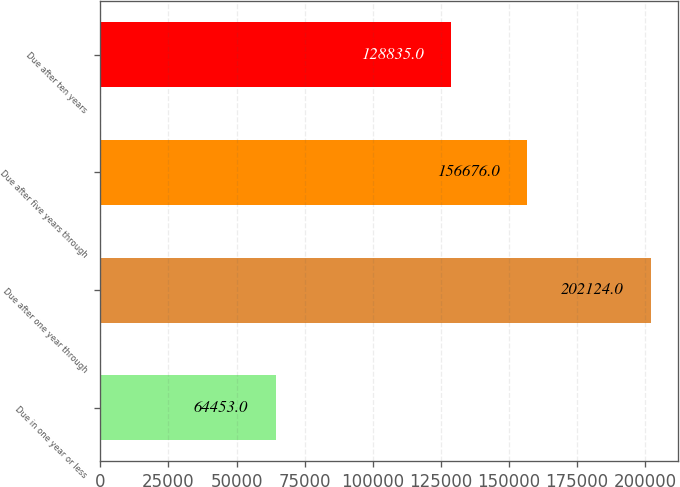<chart> <loc_0><loc_0><loc_500><loc_500><bar_chart><fcel>Due in one year or less<fcel>Due after one year through<fcel>Due after five years through<fcel>Due after ten years<nl><fcel>64453<fcel>202124<fcel>156676<fcel>128835<nl></chart> 